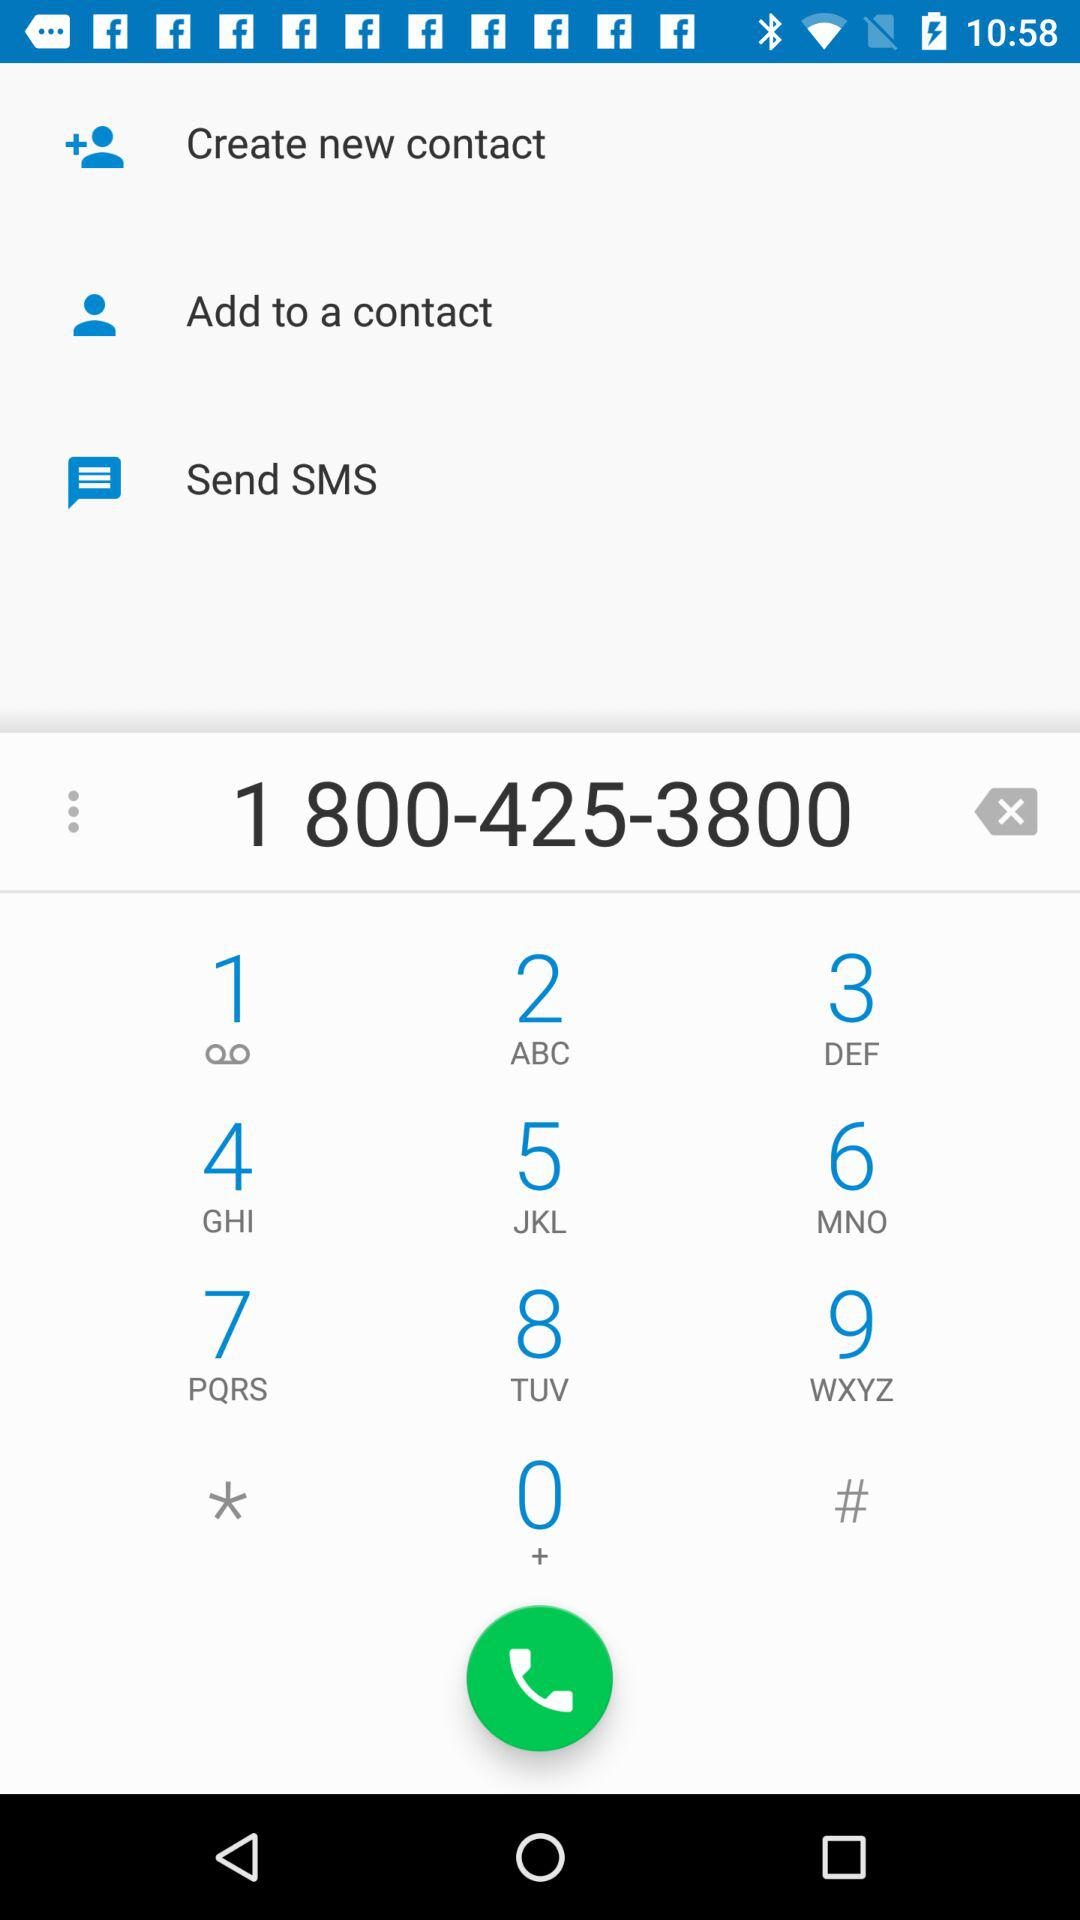What is the contact number? The contact number is 1 800-425-3800. 